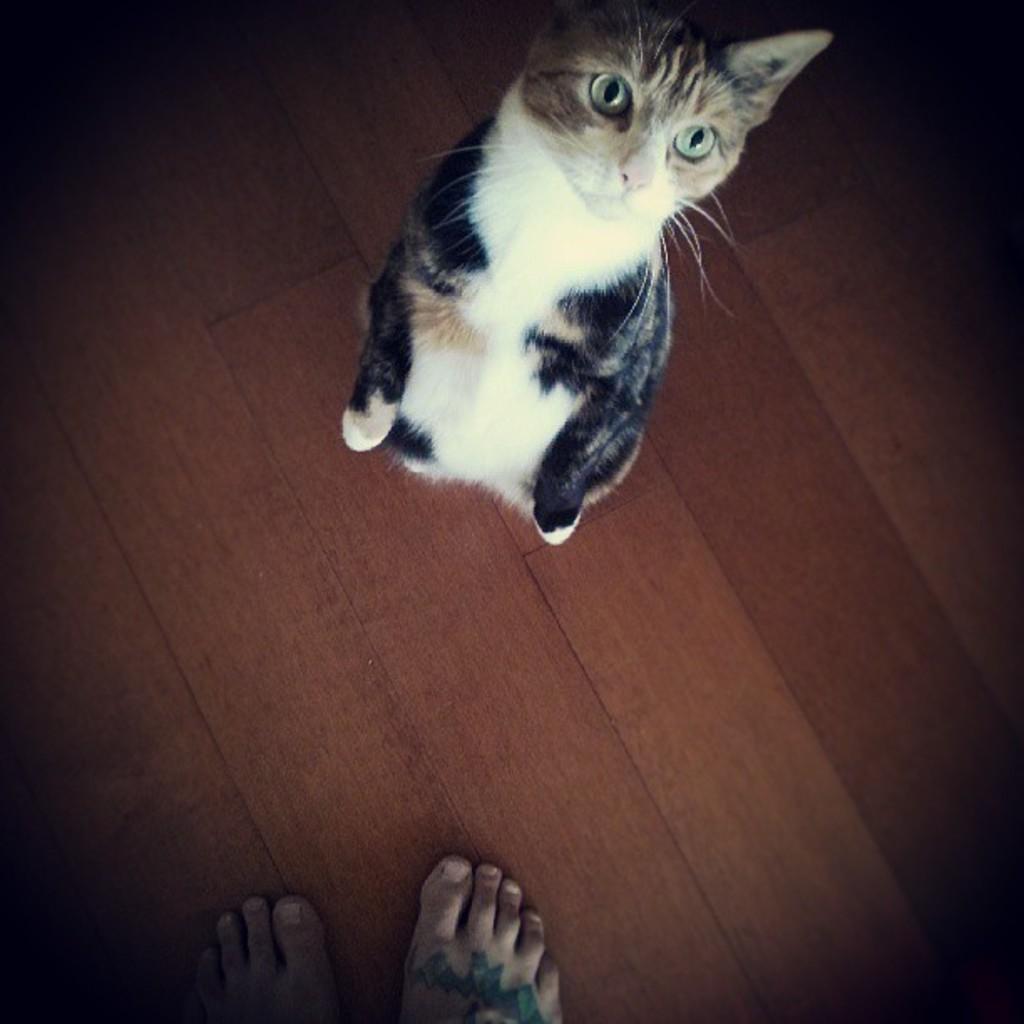Please provide a concise description of this image. In this picture I can observe cat on the floor. The cat is in white and black color. In the bottom of the picture I can observe two human legs. 